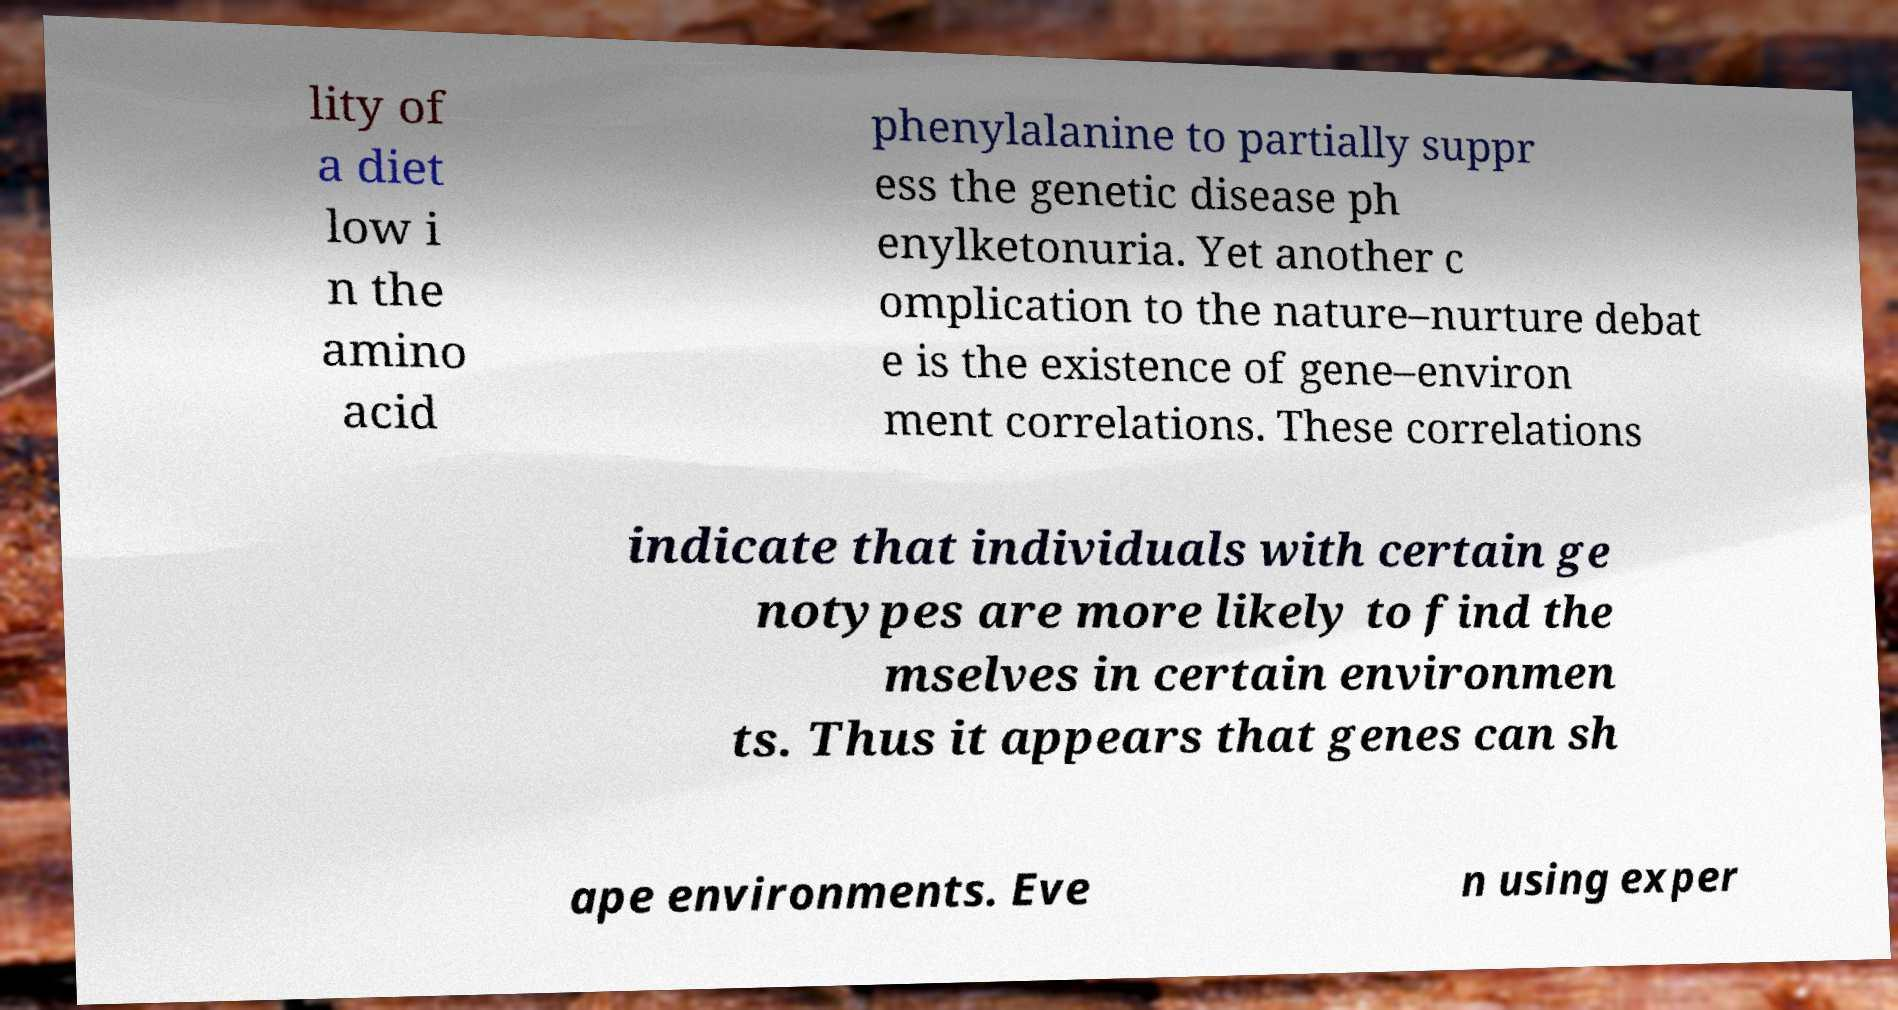Can you read and provide the text displayed in the image?This photo seems to have some interesting text. Can you extract and type it out for me? lity of a diet low i n the amino acid phenylalanine to partially suppr ess the genetic disease ph enylketonuria. Yet another c omplication to the nature–nurture debat e is the existence of gene–environ ment correlations. These correlations indicate that individuals with certain ge notypes are more likely to find the mselves in certain environmen ts. Thus it appears that genes can sh ape environments. Eve n using exper 